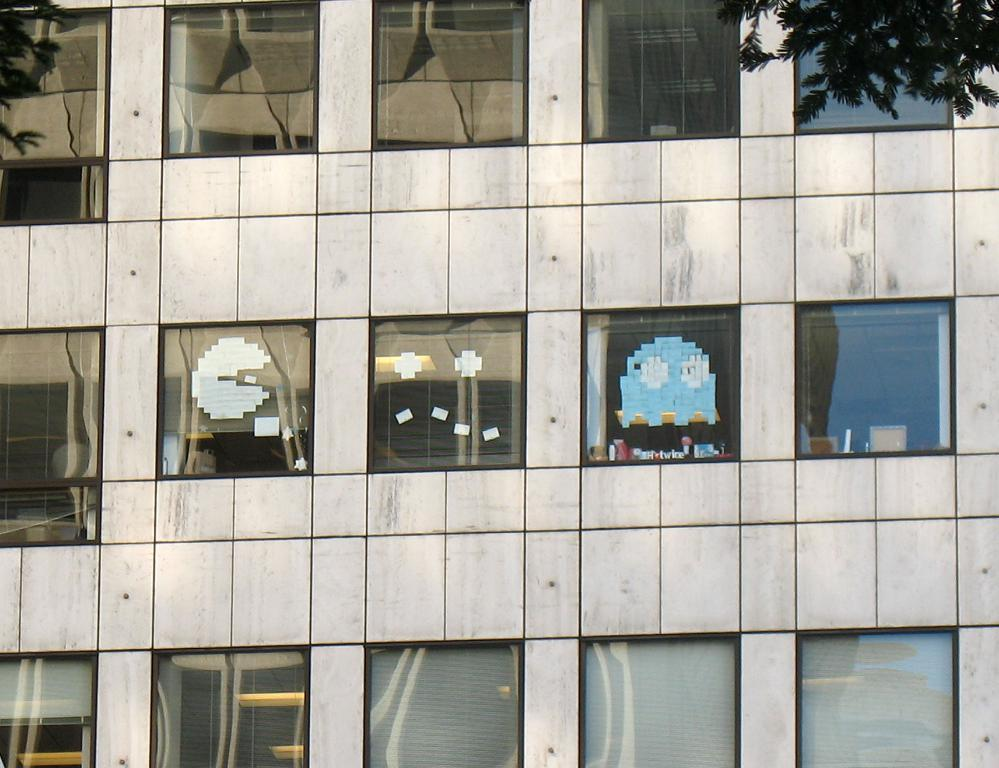What is the main structure in the picture? There is a building in the picture. What feature can be seen on the building? The building has windows. What is placed on the windows? There are stickers pasted on the windows. What can be seen on the right side of the picture? There is a tree on the right side of the picture. What type of cloth is draped over the building in the image? There is no cloth draped over the building in the image. 